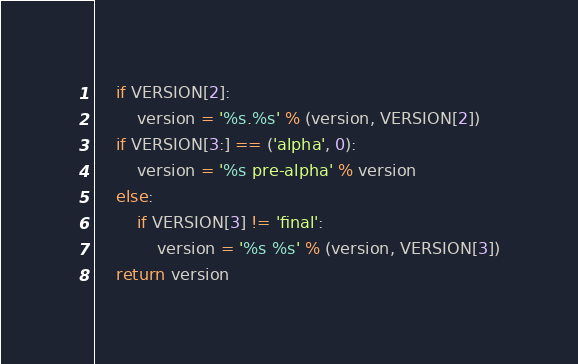Convert code to text. <code><loc_0><loc_0><loc_500><loc_500><_Python_>    if VERSION[2]:
        version = '%s.%s' % (version, VERSION[2])
    if VERSION[3:] == ('alpha', 0):
        version = '%s pre-alpha' % version
    else:
        if VERSION[3] != 'final':
            version = '%s %s' % (version, VERSION[3])
    return version
</code> 